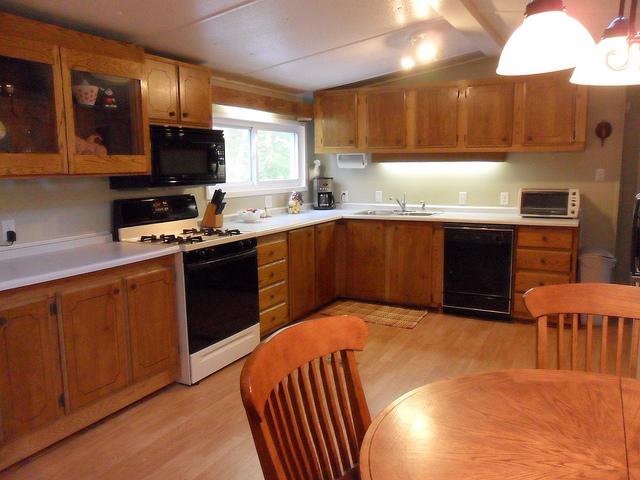Is dinner cooking on the stove?
Concise answer only. No. What material is the floor made from?
Answer briefly. Wood. How many chairs are there?
Write a very short answer. 2. 